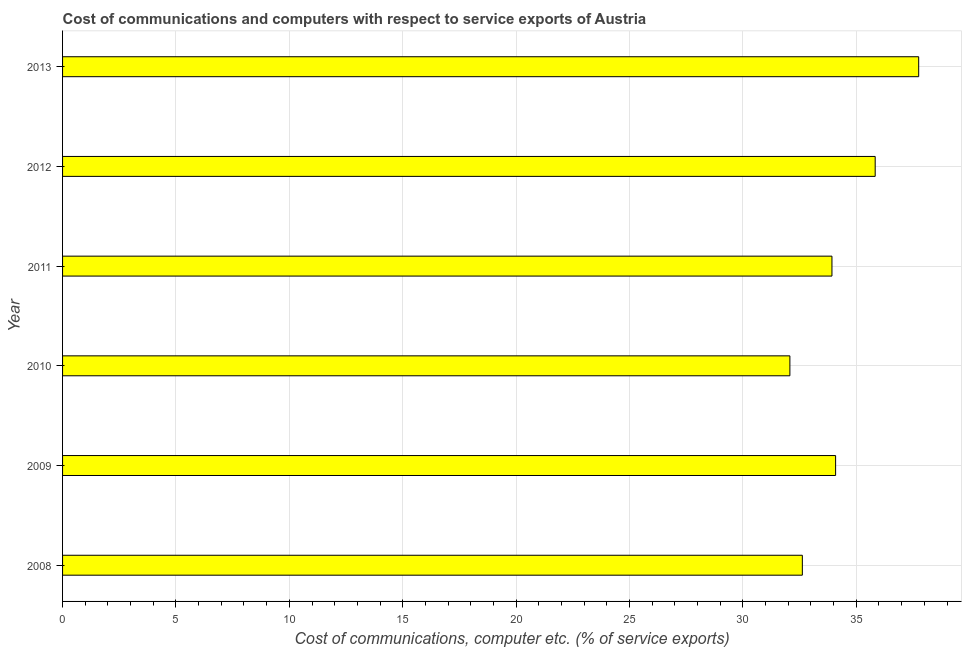What is the title of the graph?
Provide a short and direct response. Cost of communications and computers with respect to service exports of Austria. What is the label or title of the X-axis?
Your answer should be very brief. Cost of communications, computer etc. (% of service exports). What is the label or title of the Y-axis?
Provide a succinct answer. Year. What is the cost of communications and computer in 2011?
Give a very brief answer. 33.93. Across all years, what is the maximum cost of communications and computer?
Your response must be concise. 37.75. Across all years, what is the minimum cost of communications and computer?
Ensure brevity in your answer.  32.07. What is the sum of the cost of communications and computer?
Make the answer very short. 206.29. What is the difference between the cost of communications and computer in 2010 and 2011?
Offer a very short reply. -1.85. What is the average cost of communications and computer per year?
Your response must be concise. 34.38. What is the median cost of communications and computer?
Your answer should be very brief. 34.01. What is the ratio of the cost of communications and computer in 2010 to that in 2012?
Offer a very short reply. 0.9. Is the cost of communications and computer in 2009 less than that in 2011?
Provide a succinct answer. No. Is the difference between the cost of communications and computer in 2008 and 2011 greater than the difference between any two years?
Keep it short and to the point. No. What is the difference between the highest and the second highest cost of communications and computer?
Your answer should be very brief. 1.92. What is the difference between the highest and the lowest cost of communications and computer?
Provide a short and direct response. 5.68. In how many years, is the cost of communications and computer greater than the average cost of communications and computer taken over all years?
Your answer should be very brief. 2. How many bars are there?
Give a very brief answer. 6. How many years are there in the graph?
Offer a terse response. 6. What is the Cost of communications, computer etc. (% of service exports) of 2008?
Provide a short and direct response. 32.62. What is the Cost of communications, computer etc. (% of service exports) of 2009?
Provide a short and direct response. 34.09. What is the Cost of communications, computer etc. (% of service exports) in 2010?
Offer a very short reply. 32.07. What is the Cost of communications, computer etc. (% of service exports) of 2011?
Your response must be concise. 33.93. What is the Cost of communications, computer etc. (% of service exports) in 2012?
Offer a very short reply. 35.83. What is the Cost of communications, computer etc. (% of service exports) of 2013?
Give a very brief answer. 37.75. What is the difference between the Cost of communications, computer etc. (% of service exports) in 2008 and 2009?
Your answer should be compact. -1.47. What is the difference between the Cost of communications, computer etc. (% of service exports) in 2008 and 2010?
Keep it short and to the point. 0.55. What is the difference between the Cost of communications, computer etc. (% of service exports) in 2008 and 2011?
Offer a very short reply. -1.31. What is the difference between the Cost of communications, computer etc. (% of service exports) in 2008 and 2012?
Offer a terse response. -3.21. What is the difference between the Cost of communications, computer etc. (% of service exports) in 2008 and 2013?
Your answer should be compact. -5.13. What is the difference between the Cost of communications, computer etc. (% of service exports) in 2009 and 2010?
Provide a short and direct response. 2.02. What is the difference between the Cost of communications, computer etc. (% of service exports) in 2009 and 2011?
Your answer should be compact. 0.16. What is the difference between the Cost of communications, computer etc. (% of service exports) in 2009 and 2012?
Keep it short and to the point. -1.75. What is the difference between the Cost of communications, computer etc. (% of service exports) in 2009 and 2013?
Ensure brevity in your answer.  -3.66. What is the difference between the Cost of communications, computer etc. (% of service exports) in 2010 and 2011?
Make the answer very short. -1.86. What is the difference between the Cost of communications, computer etc. (% of service exports) in 2010 and 2012?
Your answer should be very brief. -3.76. What is the difference between the Cost of communications, computer etc. (% of service exports) in 2010 and 2013?
Ensure brevity in your answer.  -5.68. What is the difference between the Cost of communications, computer etc. (% of service exports) in 2011 and 2012?
Your answer should be very brief. -1.91. What is the difference between the Cost of communications, computer etc. (% of service exports) in 2011 and 2013?
Make the answer very short. -3.82. What is the difference between the Cost of communications, computer etc. (% of service exports) in 2012 and 2013?
Provide a succinct answer. -1.92. What is the ratio of the Cost of communications, computer etc. (% of service exports) in 2008 to that in 2009?
Give a very brief answer. 0.96. What is the ratio of the Cost of communications, computer etc. (% of service exports) in 2008 to that in 2010?
Give a very brief answer. 1.02. What is the ratio of the Cost of communications, computer etc. (% of service exports) in 2008 to that in 2012?
Ensure brevity in your answer.  0.91. What is the ratio of the Cost of communications, computer etc. (% of service exports) in 2008 to that in 2013?
Your response must be concise. 0.86. What is the ratio of the Cost of communications, computer etc. (% of service exports) in 2009 to that in 2010?
Make the answer very short. 1.06. What is the ratio of the Cost of communications, computer etc. (% of service exports) in 2009 to that in 2012?
Give a very brief answer. 0.95. What is the ratio of the Cost of communications, computer etc. (% of service exports) in 2009 to that in 2013?
Make the answer very short. 0.9. What is the ratio of the Cost of communications, computer etc. (% of service exports) in 2010 to that in 2011?
Your answer should be very brief. 0.94. What is the ratio of the Cost of communications, computer etc. (% of service exports) in 2010 to that in 2012?
Make the answer very short. 0.9. What is the ratio of the Cost of communications, computer etc. (% of service exports) in 2011 to that in 2012?
Offer a terse response. 0.95. What is the ratio of the Cost of communications, computer etc. (% of service exports) in 2011 to that in 2013?
Your answer should be compact. 0.9. What is the ratio of the Cost of communications, computer etc. (% of service exports) in 2012 to that in 2013?
Your answer should be compact. 0.95. 